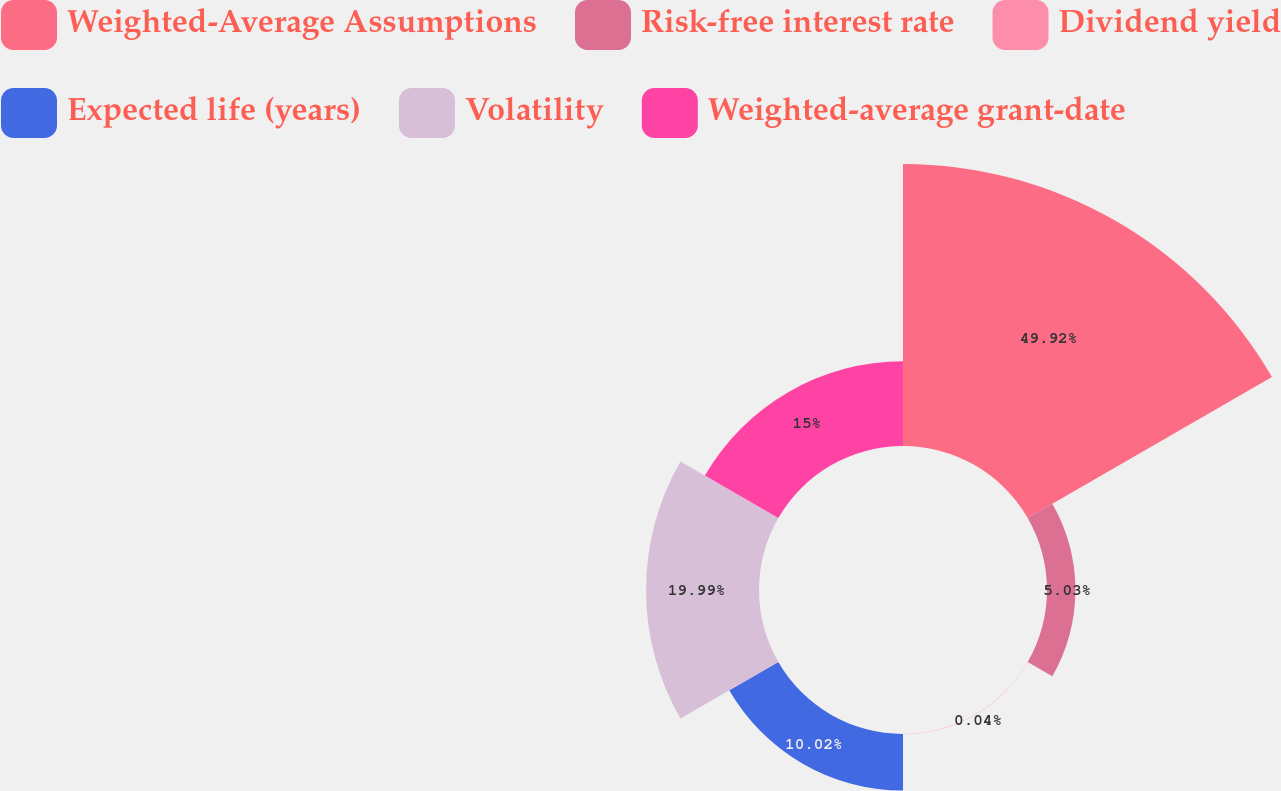Convert chart to OTSL. <chart><loc_0><loc_0><loc_500><loc_500><pie_chart><fcel>Weighted-Average Assumptions<fcel>Risk-free interest rate<fcel>Dividend yield<fcel>Expected life (years)<fcel>Volatility<fcel>Weighted-average grant-date<nl><fcel>49.91%<fcel>5.03%<fcel>0.04%<fcel>10.02%<fcel>19.99%<fcel>15.0%<nl></chart> 